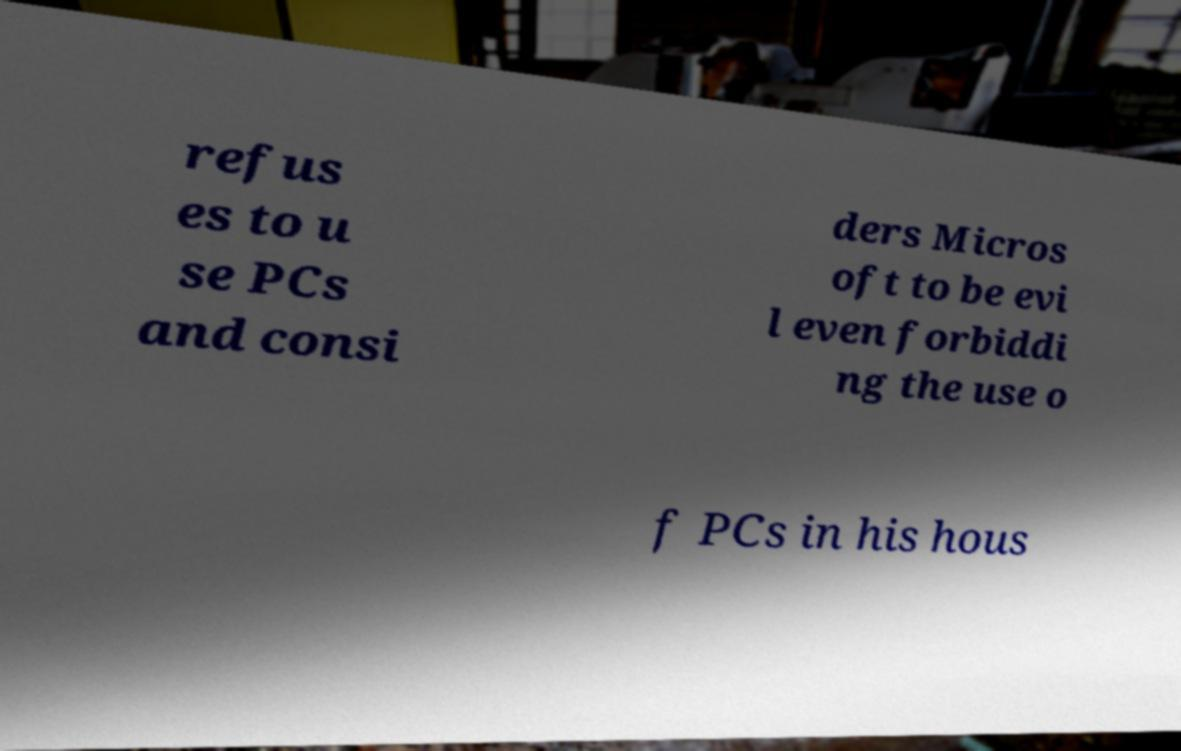Can you read and provide the text displayed in the image?This photo seems to have some interesting text. Can you extract and type it out for me? refus es to u se PCs and consi ders Micros oft to be evi l even forbiddi ng the use o f PCs in his hous 